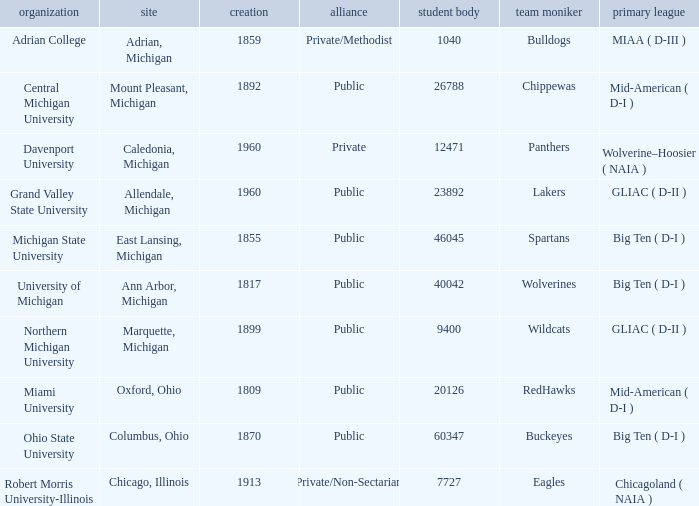Where is Robert Morris University-Illinois held? Chicago, Illinois. 